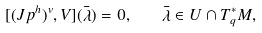Convert formula to latex. <formula><loc_0><loc_0><loc_500><loc_500>[ ( J p ^ { h } ) ^ { v } , V ] ( \bar { \lambda } ) = 0 , \quad \bar { \lambda } \in U \cap T _ { q } ^ { * } M ,</formula> 